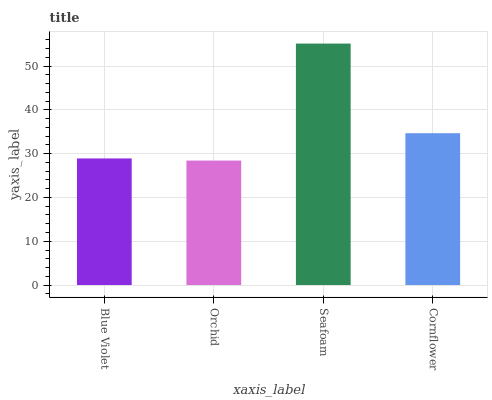Is Orchid the minimum?
Answer yes or no. Yes. Is Seafoam the maximum?
Answer yes or no. Yes. Is Seafoam the minimum?
Answer yes or no. No. Is Orchid the maximum?
Answer yes or no. No. Is Seafoam greater than Orchid?
Answer yes or no. Yes. Is Orchid less than Seafoam?
Answer yes or no. Yes. Is Orchid greater than Seafoam?
Answer yes or no. No. Is Seafoam less than Orchid?
Answer yes or no. No. Is Cornflower the high median?
Answer yes or no. Yes. Is Blue Violet the low median?
Answer yes or no. Yes. Is Seafoam the high median?
Answer yes or no. No. Is Cornflower the low median?
Answer yes or no. No. 